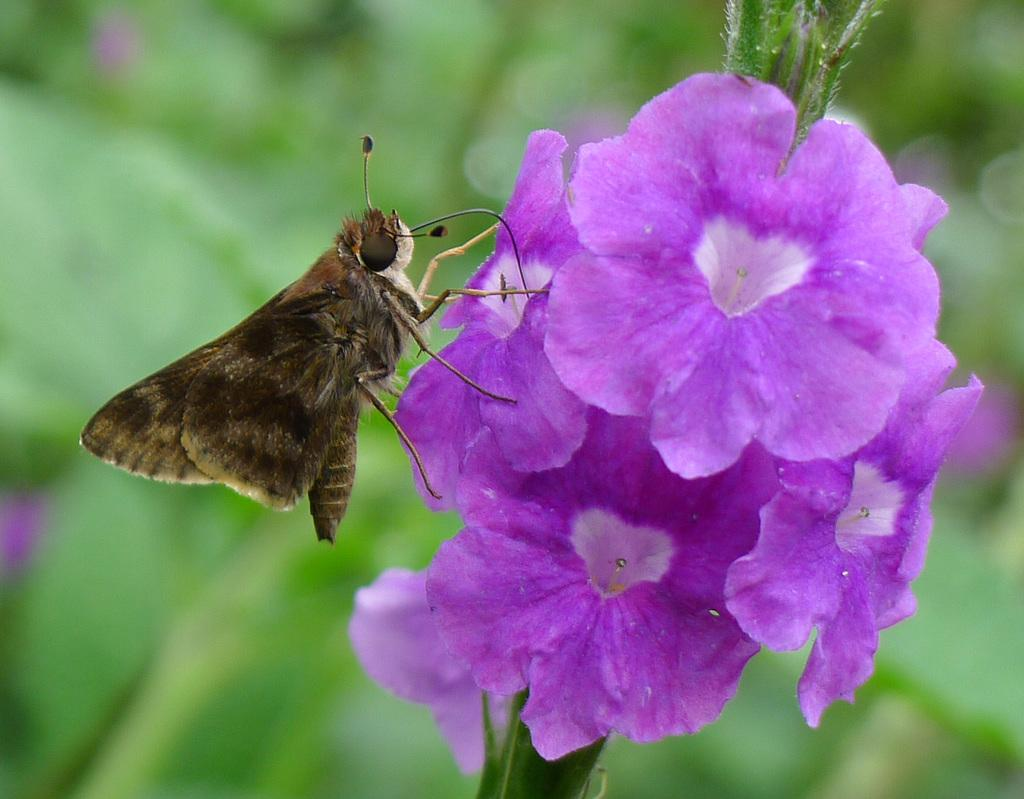What is the main subject of the image? There is a butterfly in the image. Where is the butterfly located in the image? The butterfly is sitting on a flower. What color is the flower on which the butterfly is sitting? The flower is purple. What other feature of the flower can be observed in the image? The flower has green leaves. Can you see a crown on the butterfly in the image? No, there is no crown present on the butterfly in the image. Are there any planes visible in the image? No, there are no planes present in the image. 